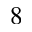<formula> <loc_0><loc_0><loc_500><loc_500>^ { 8 }</formula> 